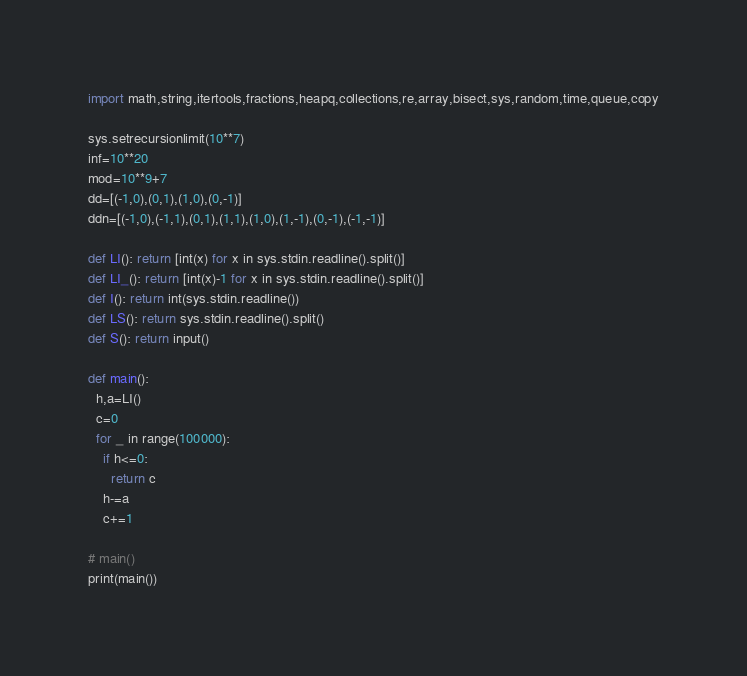Convert code to text. <code><loc_0><loc_0><loc_500><loc_500><_Python_>import math,string,itertools,fractions,heapq,collections,re,array,bisect,sys,random,time,queue,copy

sys.setrecursionlimit(10**7)
inf=10**20
mod=10**9+7
dd=[(-1,0),(0,1),(1,0),(0,-1)]
ddn=[(-1,0),(-1,1),(0,1),(1,1),(1,0),(1,-1),(0,-1),(-1,-1)]

def LI(): return [int(x) for x in sys.stdin.readline().split()]
def LI_(): return [int(x)-1 for x in sys.stdin.readline().split()]
def I(): return int(sys.stdin.readline())
def LS(): return sys.stdin.readline().split()
def S(): return input()

def main():
  h,a=LI()
  c=0
  for _ in range(100000):
    if h<=0:
      return c
    h-=a
    c+=1

# main()
print(main())
</code> 